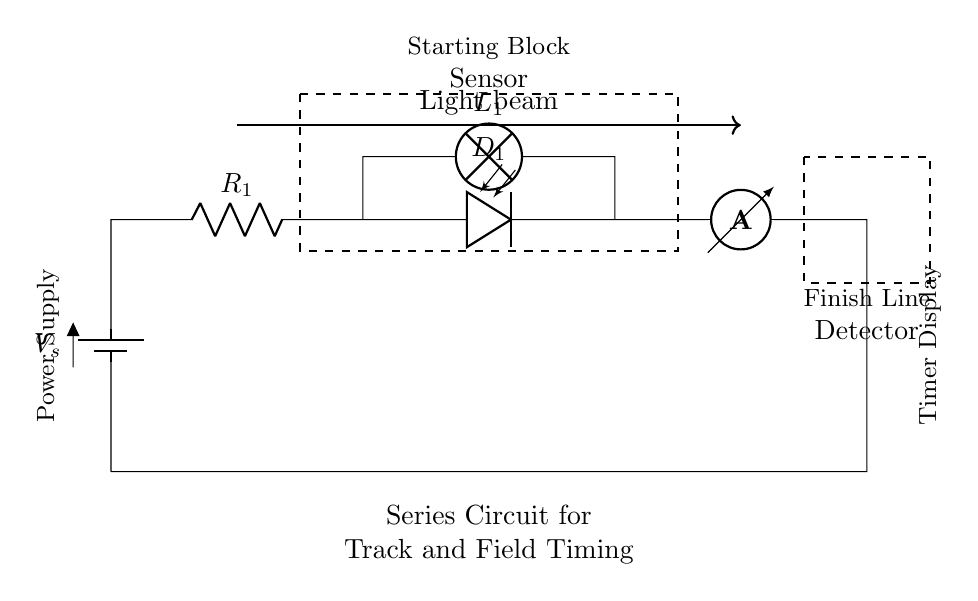What is the main power source of this circuit? The circuit uses a voltage source labeled as V_s, which is indicated by the battery symbol at the left side. This provides the necessary electrical energy for the circuit to function.
Answer: V_s How many resistors are in this circuit? The circuit diagram shows one resistor labeled as R_1, which is connected in series with the other components. This can be identified visually and through the labeled component symbol.
Answer: 1 What type of sensor is represented in the circuit? The circuit features a photodiode labeled as D_1, which is responsible for sensing light. The presence of this component is depicted in the series connection.
Answer: Photodiode What happens to the circuit when the light beam is interrupted? When the light beam (shown by the thick arrow) is interrupted, the photodiode D_1 will trigger a change in current flow through the circuit, stopping the timer display. The light beam is a crucial part of the timing mechanism in track and field.
Answer: Timer stops What does the lamp in the circuit represent? The lamp labeled L_1 serves as a visual indication or alert, illuminating when the circuit is completed and current flows through it. It is located in the series circuit and is part of the sensor mechanism.
Answer: Indicator What is the role of the ammeter in this circuit? The ammeter is used to measure the current flowing through the series circuit. It is positioned at the end of the circuit, reflecting the current's value in the system, providing important data for timing performance.
Answer: Current measurement What type of circuit configuration is used here? The configuration depicted in the circuit diagram is a series circuit, which means that all components are connected end-to-end, sharing the same current. This is evidenced by the linear connection of the battery, resistor, sensor, and ammeter.
Answer: Series circuit 